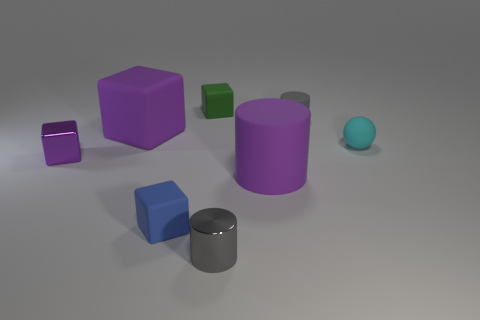Does the large cylinder have the same color as the small shiny block?
Your response must be concise. Yes. Is the shape of the purple thing that is behind the small purple cube the same as the tiny shiny object that is left of the small blue thing?
Ensure brevity in your answer.  Yes. There is a tiny purple object that is the same shape as the blue object; what material is it?
Offer a terse response. Metal. What is the color of the thing that is both behind the tiny ball and to the left of the tiny green matte block?
Make the answer very short. Purple. Is there a cube that is in front of the thing behind the gray thing that is behind the small gray metallic thing?
Provide a succinct answer. Yes. How many objects are either tiny cyan matte things or big rubber cubes?
Provide a succinct answer. 2. Are the small ball and the tiny gray thing that is in front of the small ball made of the same material?
Provide a succinct answer. No. Is there anything else that has the same color as the big matte cube?
Your response must be concise. Yes. How many things are either objects that are on the right side of the blue object or big purple rubber things on the left side of the tiny blue block?
Provide a short and direct response. 6. The tiny matte thing that is both in front of the gray rubber cylinder and to the left of the tiny cyan thing has what shape?
Provide a succinct answer. Cube. 